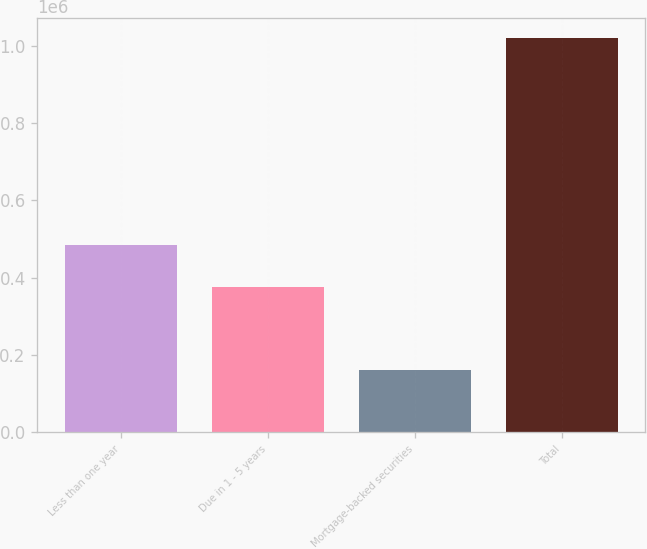Convert chart to OTSL. <chart><loc_0><loc_0><loc_500><loc_500><bar_chart><fcel>Less than one year<fcel>Due in 1 - 5 years<fcel>Mortgage-backed securities<fcel>Total<nl><fcel>484616<fcel>374855<fcel>161199<fcel>1.02067e+06<nl></chart> 